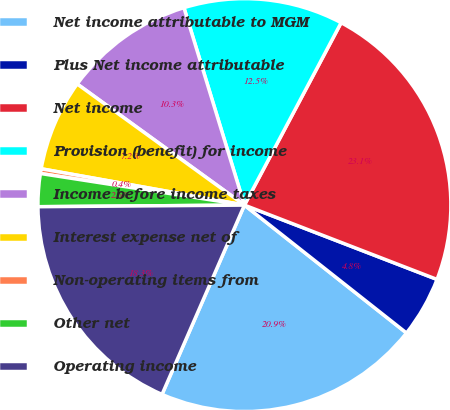Convert chart. <chart><loc_0><loc_0><loc_500><loc_500><pie_chart><fcel>Net income attributable to MGM<fcel>Plus Net income attributable<fcel>Net income<fcel>Provision (benefit) for income<fcel>Income before income taxes<fcel>Interest expense net of<fcel>Non-operating items from<fcel>Other net<fcel>Operating income<nl><fcel>20.9%<fcel>4.77%<fcel>23.1%<fcel>12.49%<fcel>10.29%<fcel>7.16%<fcel>0.37%<fcel>2.57%<fcel>18.34%<nl></chart> 